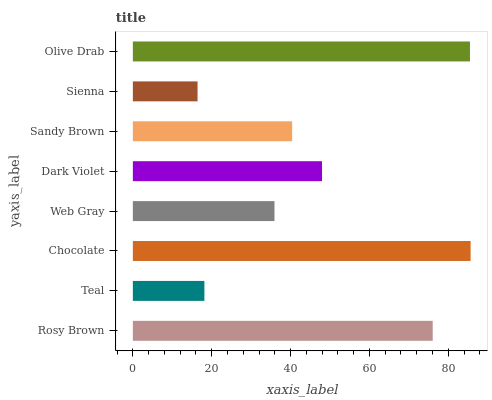Is Sienna the minimum?
Answer yes or no. Yes. Is Chocolate the maximum?
Answer yes or no. Yes. Is Teal the minimum?
Answer yes or no. No. Is Teal the maximum?
Answer yes or no. No. Is Rosy Brown greater than Teal?
Answer yes or no. Yes. Is Teal less than Rosy Brown?
Answer yes or no. Yes. Is Teal greater than Rosy Brown?
Answer yes or no. No. Is Rosy Brown less than Teal?
Answer yes or no. No. Is Dark Violet the high median?
Answer yes or no. Yes. Is Sandy Brown the low median?
Answer yes or no. Yes. Is Sandy Brown the high median?
Answer yes or no. No. Is Teal the low median?
Answer yes or no. No. 